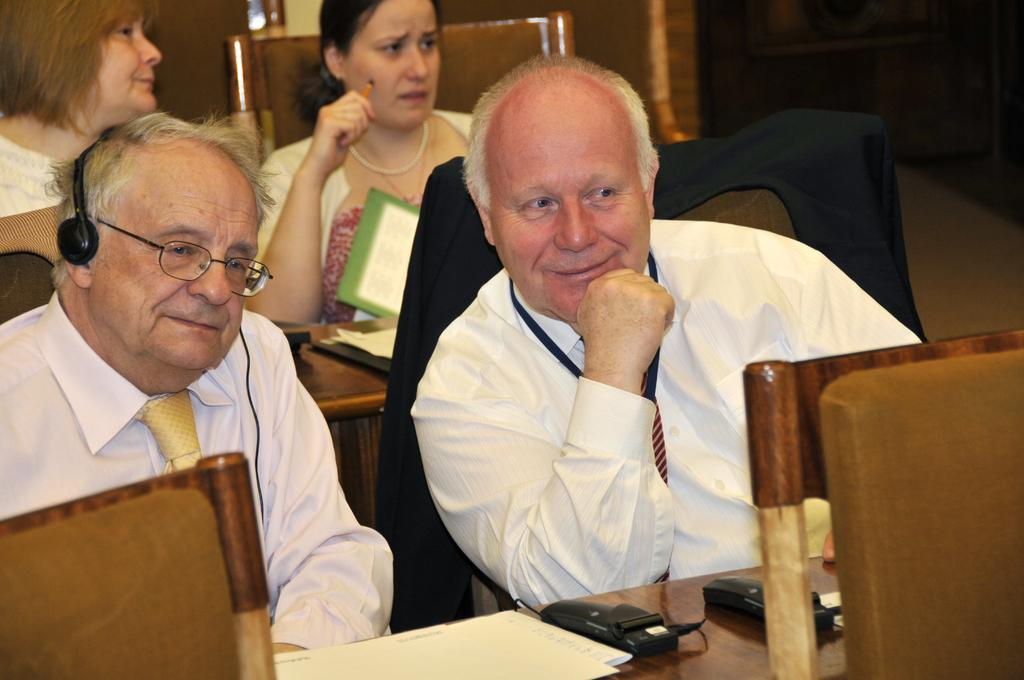What is happening in the image? There is a group of people in the image, and they are sitting in chairs. What is present on the table in the image? There are papers on the table in the image. Can you describe the setting where the people are sitting? The people are sitting in chairs around a table. What type of record is being played in the background of the image? There is no record being played in the background of the image. Can you see a tramp performing tricks in the image? There is no tramp performing tricks in the image. 